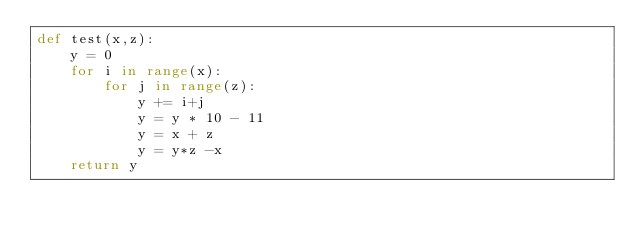Convert code to text. <code><loc_0><loc_0><loc_500><loc_500><_Python_>def test(x,z):
    y = 0
    for i in range(x):
        for j in range(z):
            y += i+j
            y = y * 10 - 11
            y = x + z
            y = y*z -x
    return y
</code> 